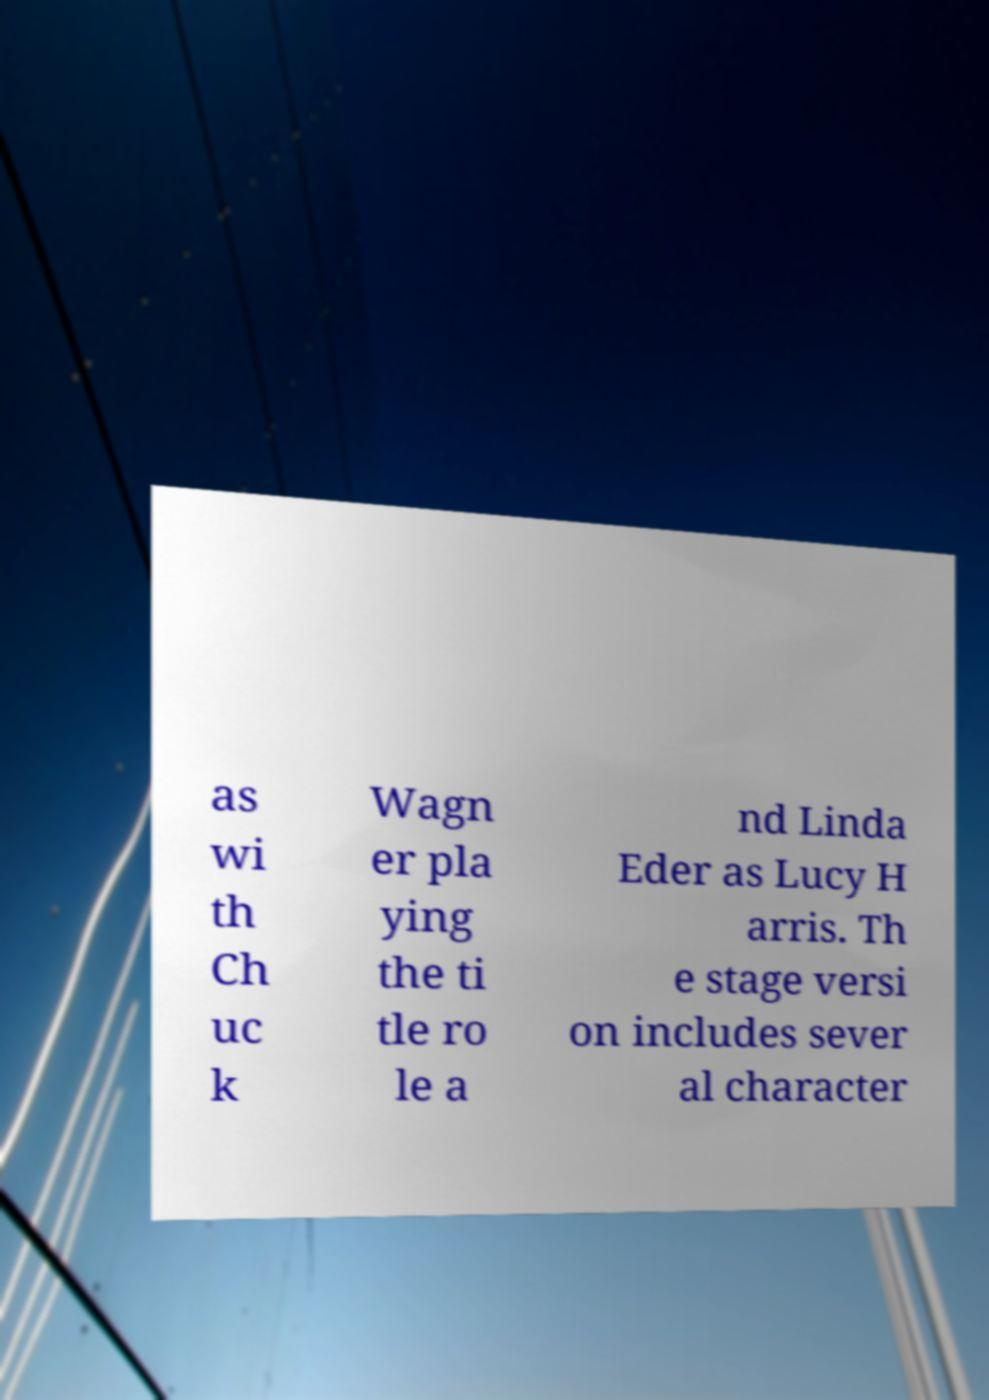I need the written content from this picture converted into text. Can you do that? as wi th Ch uc k Wagn er pla ying the ti tle ro le a nd Linda Eder as Lucy H arris. Th e stage versi on includes sever al character 